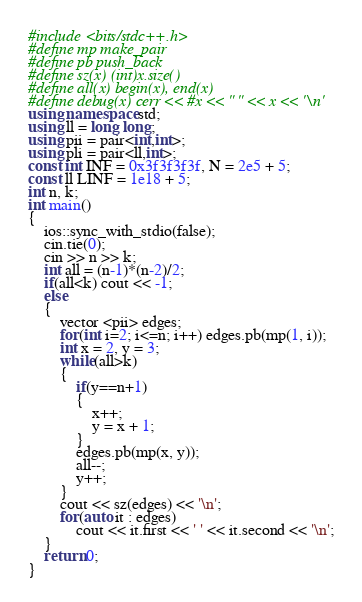Convert code to text. <code><loc_0><loc_0><loc_500><loc_500><_C++_>#include <bits/stdc++.h>
#define mp make_pair
#define pb push_back
#define sz(x) (int)x.size()
#define all(x) begin(x), end(x)
#define debug(x) cerr << #x << " " << x << '\n'
using namespace std;
using ll = long long;
using pii = pair<int,int>;
using pli = pair<ll,int>;
const int INF = 0x3f3f3f3f, N = 2e5 + 5;
const ll LINF = 1e18 + 5;
int n, k;
int main()
{
 	ios::sync_with_stdio(false);
 	cin.tie(0);
 	cin >> n >> k;
 	int all = (n-1)*(n-2)/2;
 	if(all<k) cout << -1;
 	else
 	{
 		vector <pii> edges;
		for(int i=2; i<=n; i++) edges.pb(mp(1, i));
		int x = 2, y = 3;
		while(all>k)
		{
			if(y==n+1)
			{
				x++;
				y = x + 1;
			}
			edges.pb(mp(x, y));
			all--;
			y++;
		}
		cout << sz(edges) << '\n';
		for(auto it : edges)
			cout << it.first << ' ' << it.second << '\n';
	}
	return 0;
}
</code> 